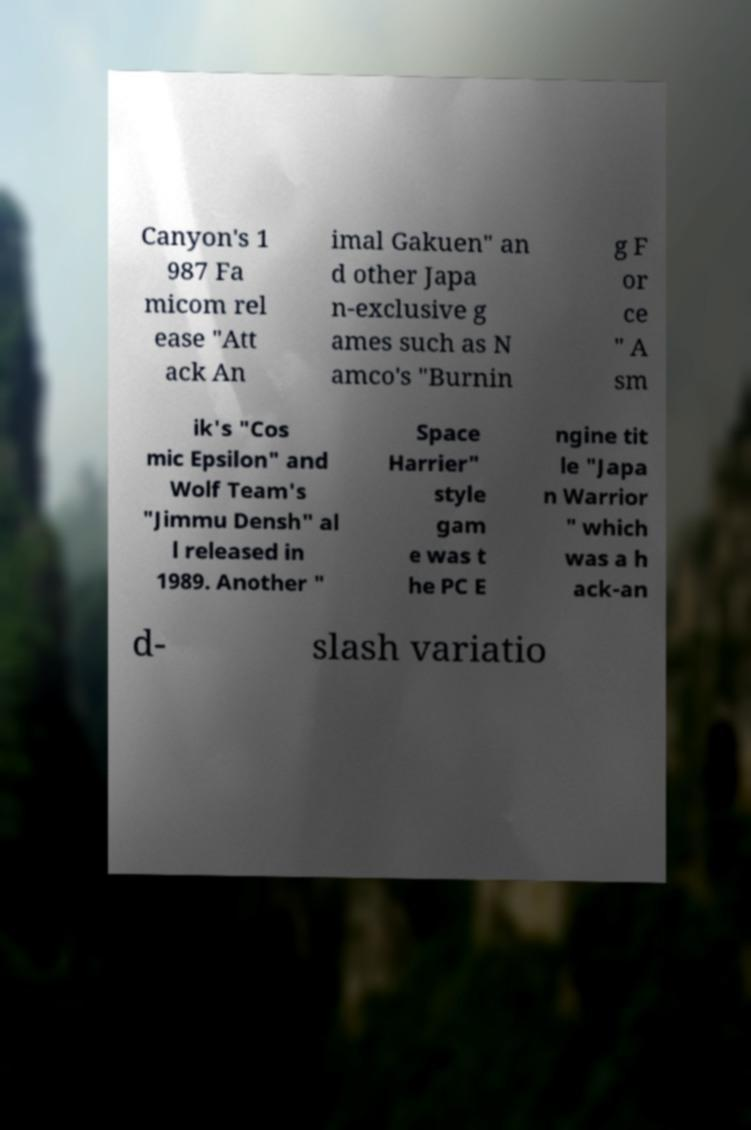I need the written content from this picture converted into text. Can you do that? Canyon's 1 987 Fa micom rel ease "Att ack An imal Gakuen" an d other Japa n-exclusive g ames such as N amco's "Burnin g F or ce " A sm ik's "Cos mic Epsilon" and Wolf Team's "Jimmu Densh" al l released in 1989. Another " Space Harrier" style gam e was t he PC E ngine tit le "Japa n Warrior " which was a h ack-an d- slash variatio 